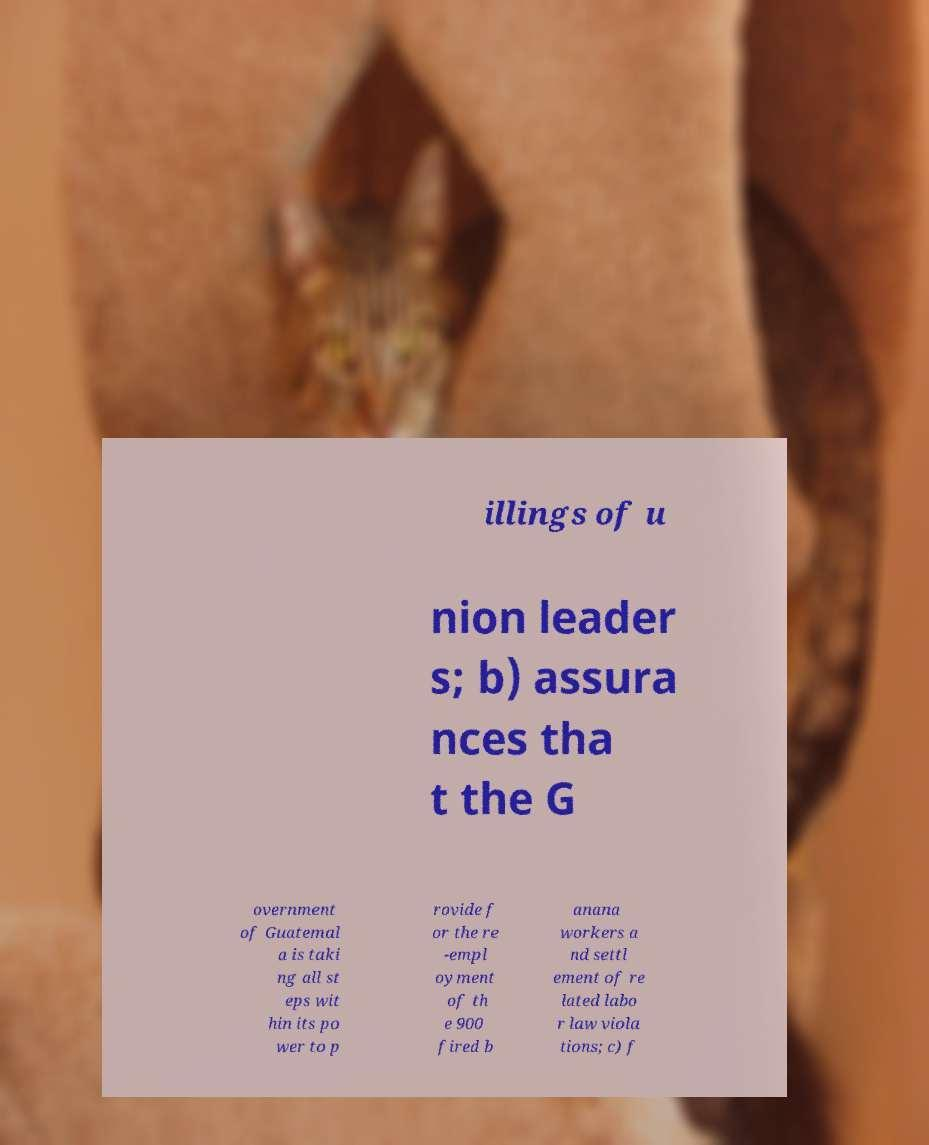What messages or text are displayed in this image? I need them in a readable, typed format. illings of u nion leader s; b) assura nces tha t the G overnment of Guatemal a is taki ng all st eps wit hin its po wer to p rovide f or the re -empl oyment of th e 900 fired b anana workers a nd settl ement of re lated labo r law viola tions; c) f 